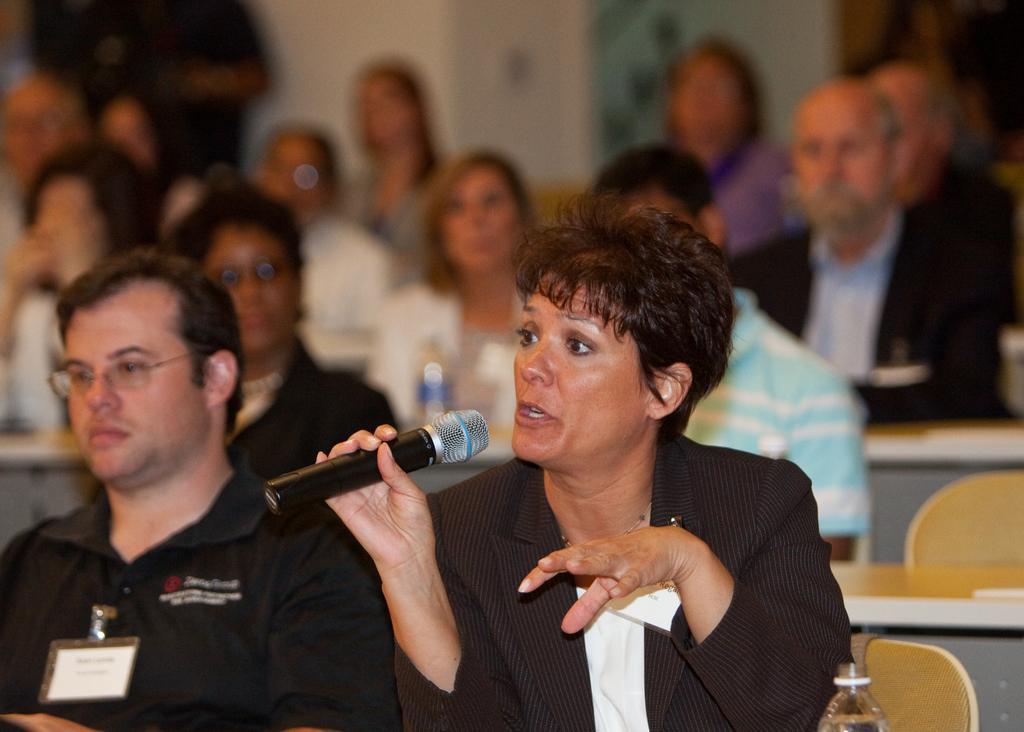Could you give a brief overview of what you see in this image? It is a picture,a woman is is talking something she is sitting in the front row there is a man to the left side of her, in the background there are some other people and the wall is of white color. 